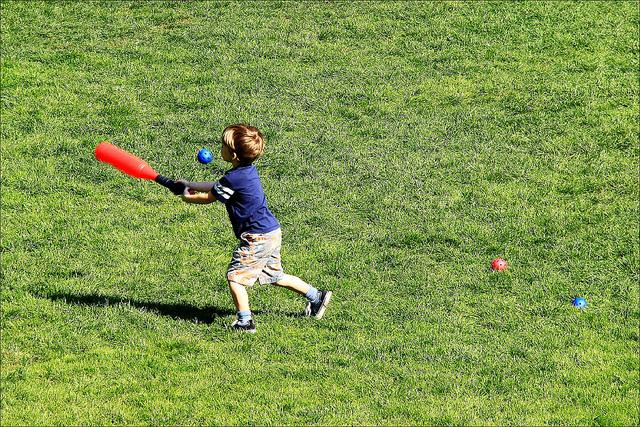Why does the boy have his arms out? hitting ball 